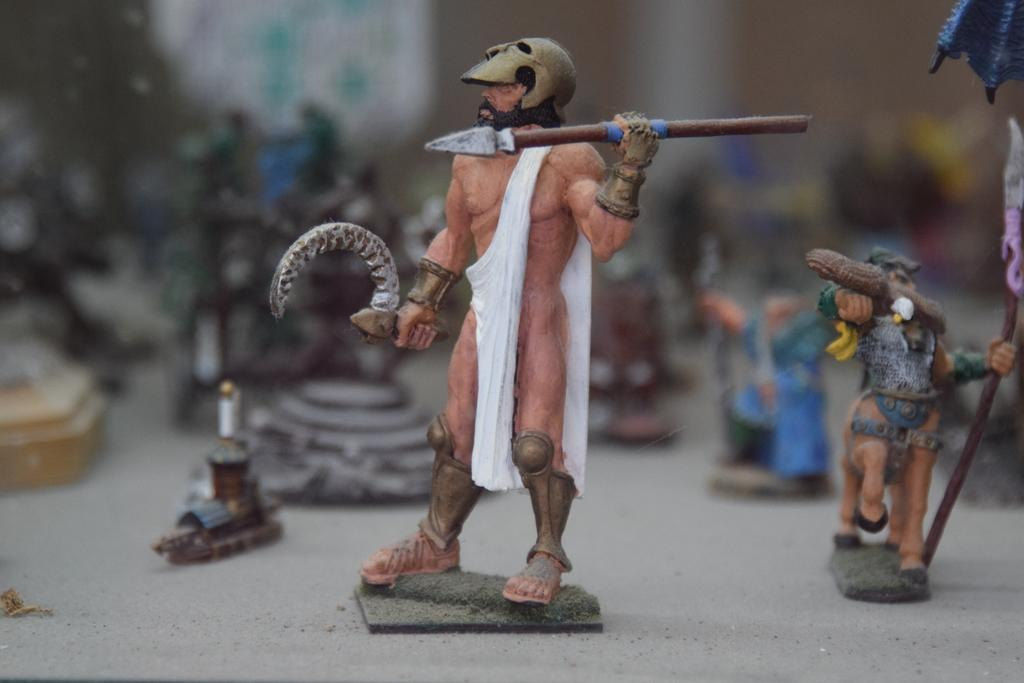What objects can be seen in the image? There are toys in the image. Can you describe the background of the image? The background of the image is blurred. Are there any icicles hanging from the toys in the image? There are no icicles present in the image. What type of journey is depicted in the image? There is no journey depicted in the image; it features toys and a blurred background. 